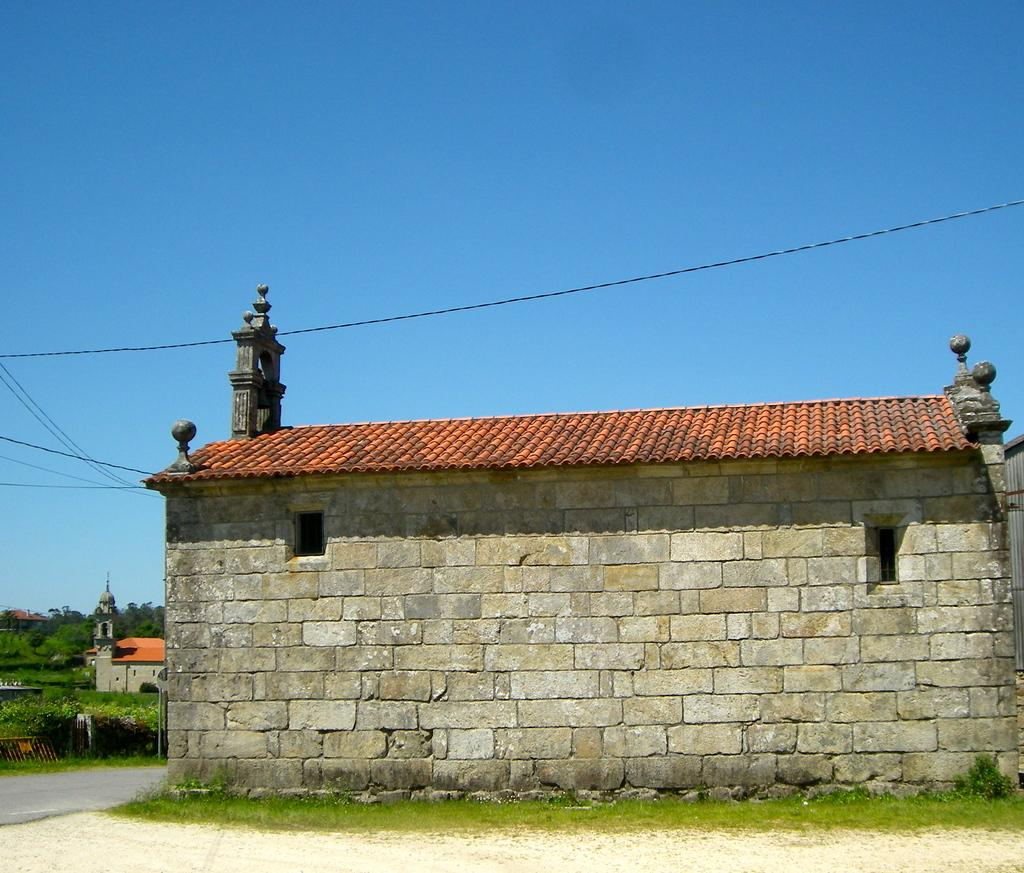What type of structures can be seen in the image? There are houses in the image. What natural elements are present in the image? There are trees in the image. What man-made objects can be seen in the image? There are wires in the image. What type of vegetation is visible in the image? There are small plants in the image. What is the color of the sky in the image? The sky is blue in color. Where is the store located in the image? There is no store present in the image. What type of alley can be seen in the image? There is no alley present in the image. 